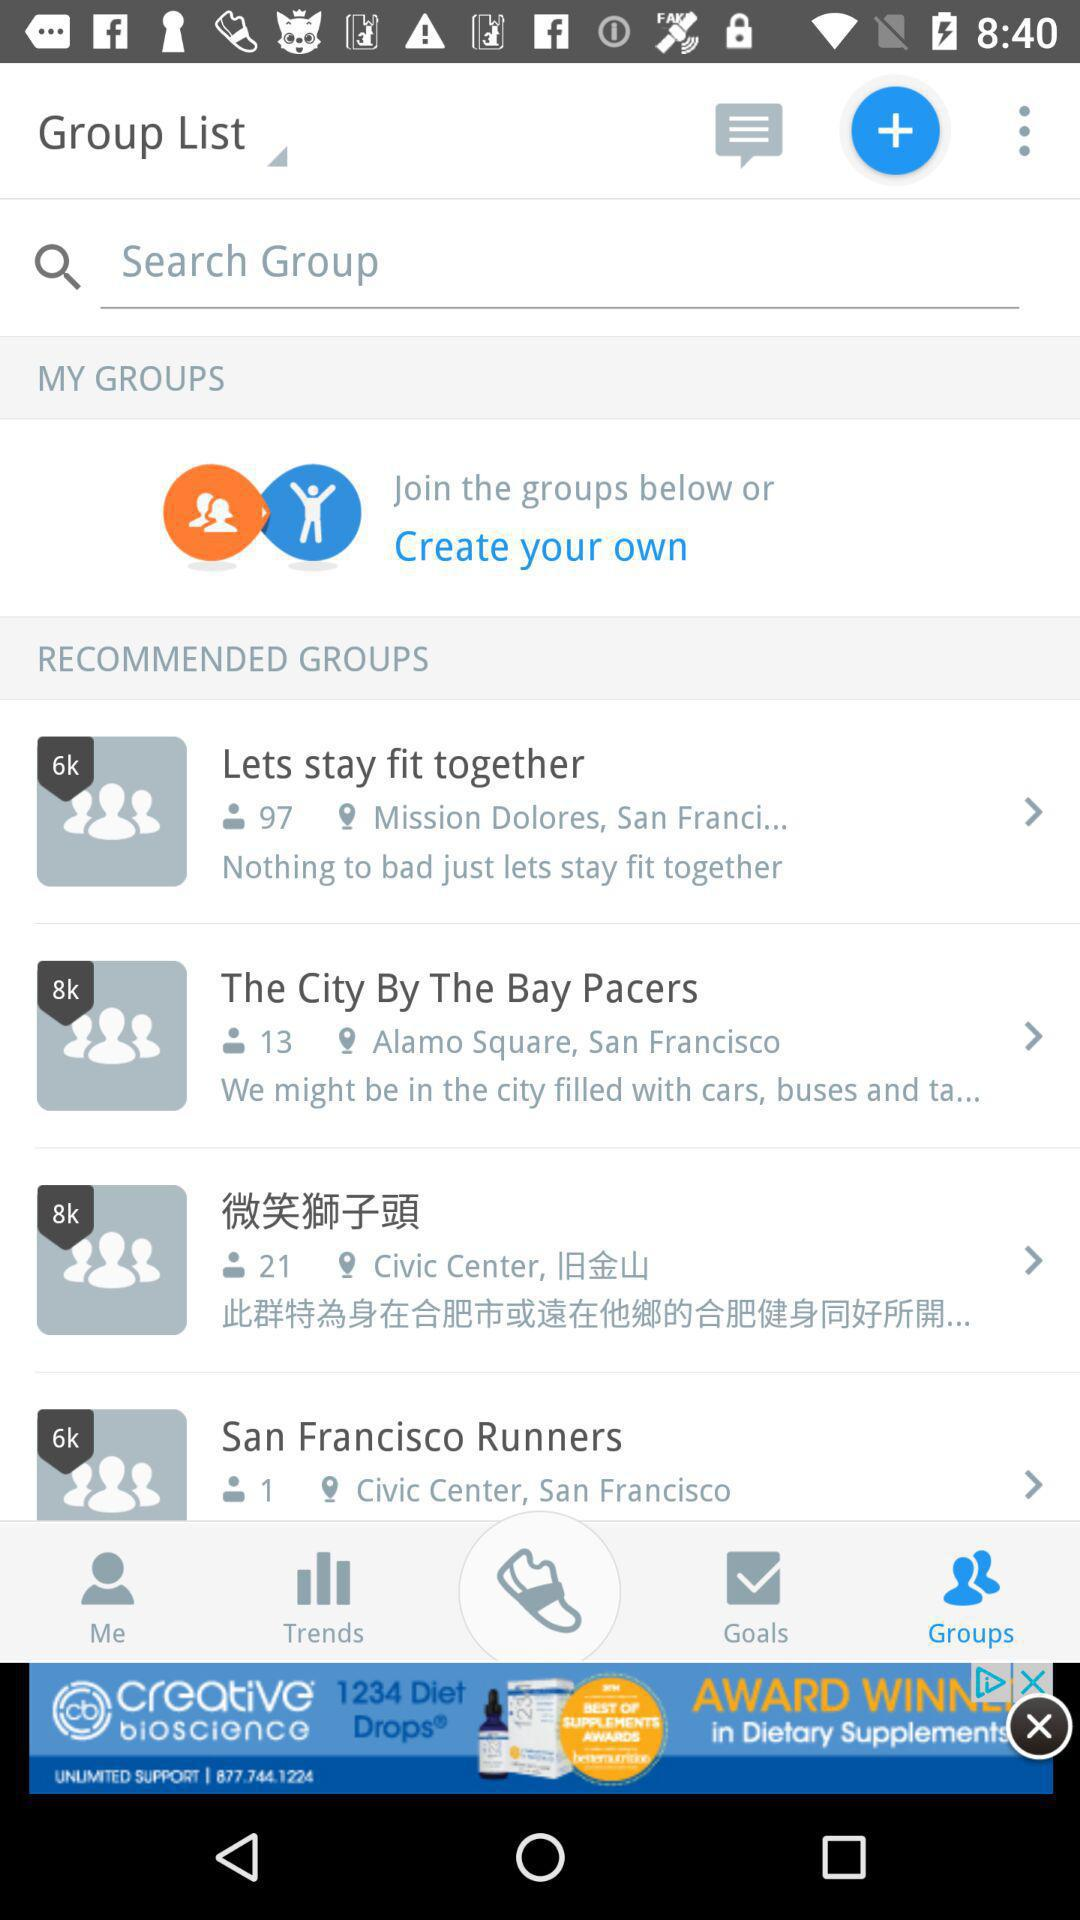Which given group has the address "Alamo Square" in San Francisco? The given group that has the address "Alamo Square" in San Francisco is "The City By The Bay Pacers". 